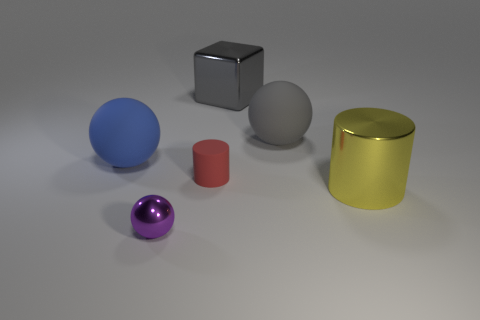Add 3 large purple shiny cylinders. How many objects exist? 9 Subtract all cylinders. How many objects are left? 4 Subtract 0 yellow balls. How many objects are left? 6 Subtract all large green balls. Subtract all metallic blocks. How many objects are left? 5 Add 6 small things. How many small things are left? 8 Add 2 tiny gray rubber balls. How many tiny gray rubber balls exist? 2 